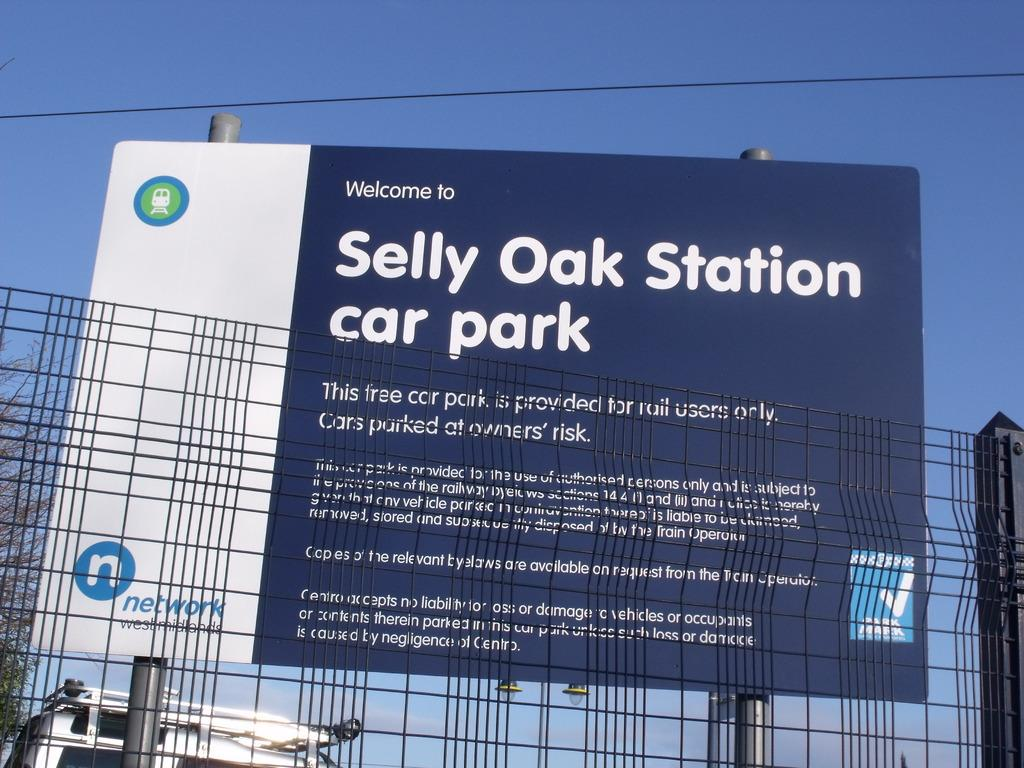<image>
Render a clear and concise summary of the photo. A blue sign for Selly Oak Station car park with white writing 